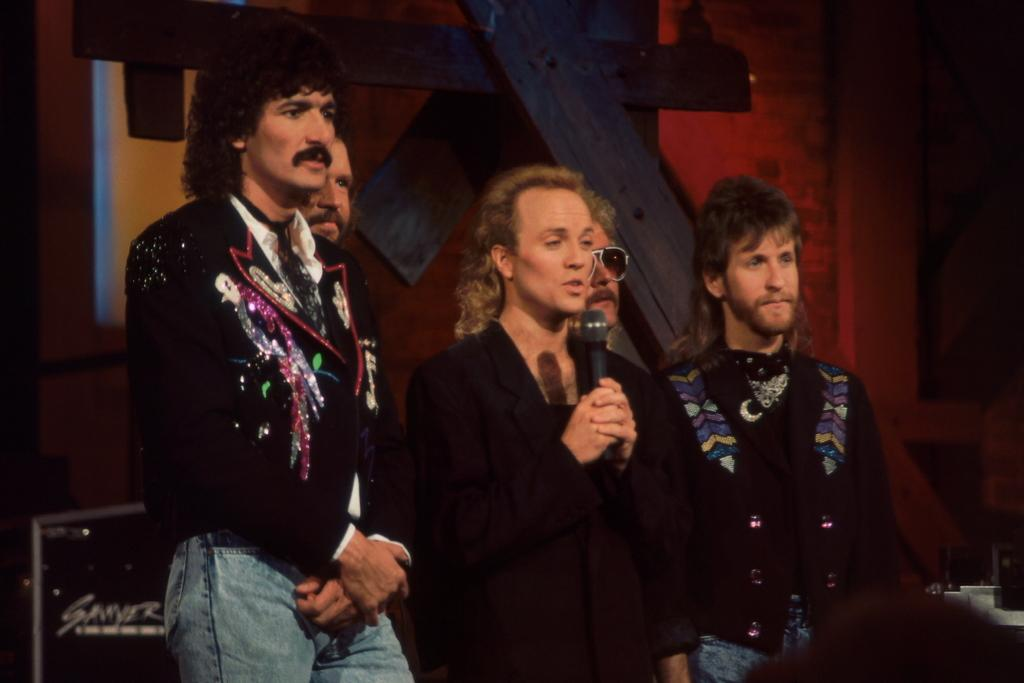What are the people in the image doing? The people in the center of the image are standing. What is the person in the center holding? The center person is holding a microphone. What can be seen in the background of the image? There is a wall and a board in the background of the image, along with other objects. What type of fuel is being used by the brothers in the image? There are no brothers present in the image, and no fuel is mentioned or visible. 